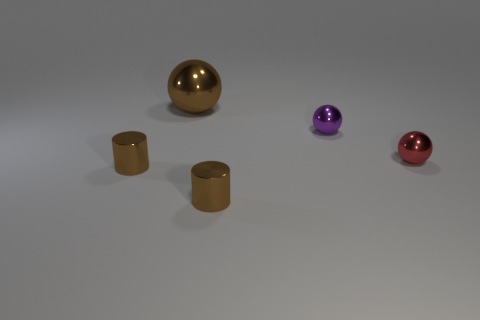How many objects are there and what are their colors? There are five objects in total. From left to right, there is a golden sphere, a golden cylinder, a purple sphere, a second golden cylinder, and a small red sphere. 